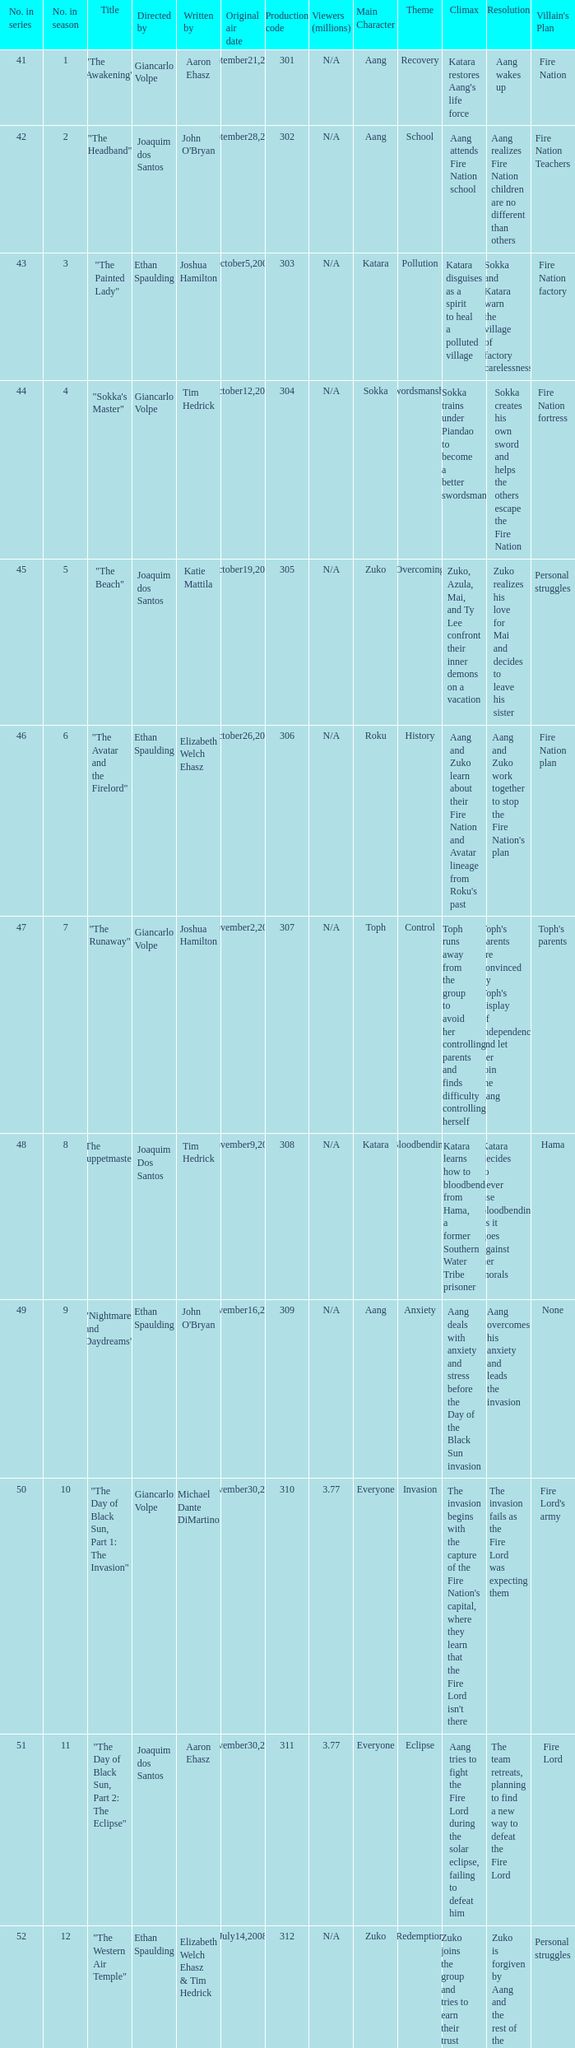What are all the numbers in the series with an episode title of "the beach"? 45.0. 